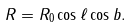Convert formula to latex. <formula><loc_0><loc_0><loc_500><loc_500>R = R _ { 0 } \cos \ell \cos b .</formula> 